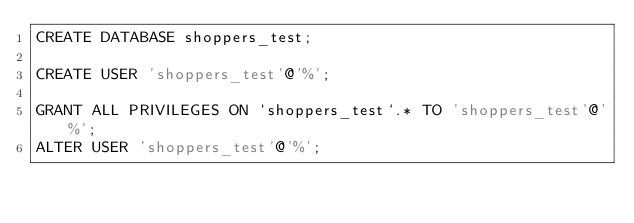<code> <loc_0><loc_0><loc_500><loc_500><_SQL_>CREATE DATABASE shoppers_test;

CREATE USER 'shoppers_test'@'%';

GRANT ALL PRIVILEGES ON `shoppers_test`.* TO 'shoppers_test'@'%';
ALTER USER 'shoppers_test'@'%';
</code> 